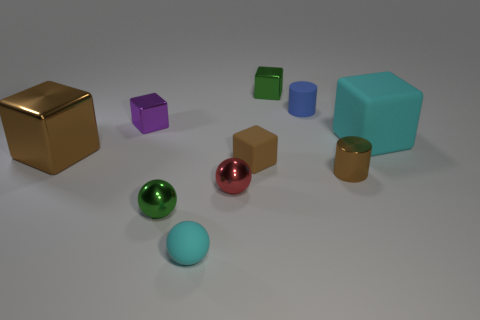Subtract all gray balls. How many brown cubes are left? 2 Subtract all tiny metallic balls. How many balls are left? 1 Subtract all cyan blocks. How many blocks are left? 4 Subtract 1 balls. How many balls are left? 2 Subtract all big yellow metal balls. Subtract all small cyan matte objects. How many objects are left? 9 Add 3 small blue cylinders. How many small blue cylinders are left? 4 Add 4 cyan objects. How many cyan objects exist? 6 Subtract 0 green cylinders. How many objects are left? 10 Subtract all cylinders. How many objects are left? 8 Subtract all blue cylinders. Subtract all red spheres. How many cylinders are left? 1 